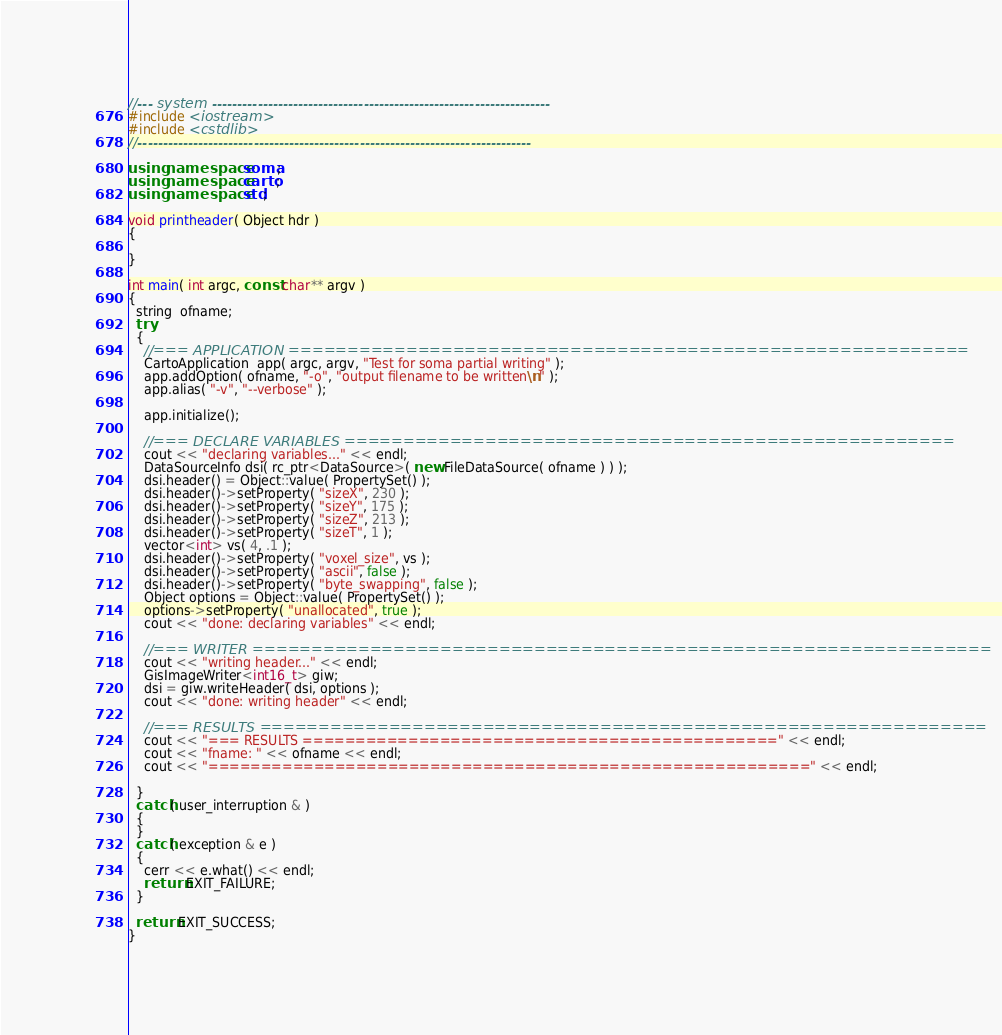Convert code to text. <code><loc_0><loc_0><loc_500><loc_500><_C++_>//--- system -------------------------------------------------------------------
#include <iostream>
#include <cstdlib>
//------------------------------------------------------------------------------

using namespace soma;
using namespace carto;
using namespace std;

void printheader( Object hdr )
{
  
}

int main( int argc, const char** argv )
{
  string  ofname;
  try
  {
    //=== APPLICATION ==========================================================
    CartoApplication  app( argc, argv, "Test for soma partial writing" );
    app.addOption( ofname, "-o", "output filename to be written\n" );
    app.alias( "-v", "--verbose" );

    app.initialize();
    
    //=== DECLARE VARIABLES ====================================================
    cout << "declaring variables..." << endl;
    DataSourceInfo dsi( rc_ptr<DataSource>( new FileDataSource( ofname ) ) );
    dsi.header() = Object::value( PropertySet() );
    dsi.header()->setProperty( "sizeX", 230 );
    dsi.header()->setProperty( "sizeY", 175 );
    dsi.header()->setProperty( "sizeZ", 213 );
    dsi.header()->setProperty( "sizeT", 1 );
    vector<int> vs( 4, .1 );
    dsi.header()->setProperty( "voxel_size", vs );
    dsi.header()->setProperty( "ascii", false );
    dsi.header()->setProperty( "byte_swapping", false );
    Object options = Object::value( PropertySet() );
    options->setProperty( "unallocated", true );
    cout << "done: declaring variables" << endl;

    //=== WRITER ===============================================================
    cout << "writing header..." << endl;
    GisImageWriter<int16_t> giw;
    dsi = giw.writeHeader( dsi, options );
    cout << "done: writing header" << endl;
    
    //=== RESULTS ==============================================================
    cout << "=== RESULTS =============================================" << endl;
    cout << "fname: " << ofname << endl;
    cout << "=========================================================" << endl;
    
  }
  catch( user_interruption & )
  {
  }
  catch( exception & e )
  {
    cerr << e.what() << endl;
    return EXIT_FAILURE;
  }

  return EXIT_SUCCESS;
}

</code> 